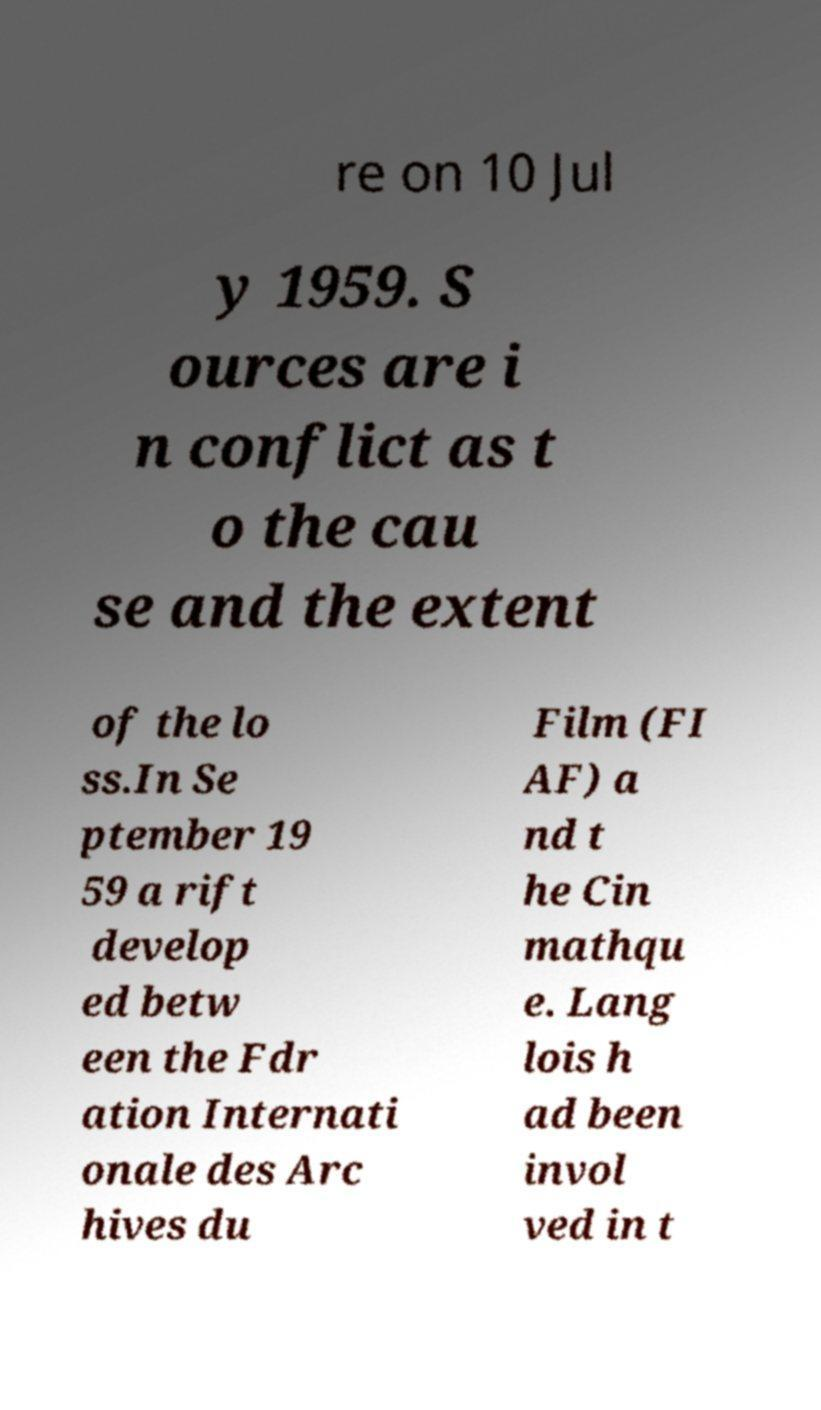There's text embedded in this image that I need extracted. Can you transcribe it verbatim? re on 10 Jul y 1959. S ources are i n conflict as t o the cau se and the extent of the lo ss.In Se ptember 19 59 a rift develop ed betw een the Fdr ation Internati onale des Arc hives du Film (FI AF) a nd t he Cin mathqu e. Lang lois h ad been invol ved in t 